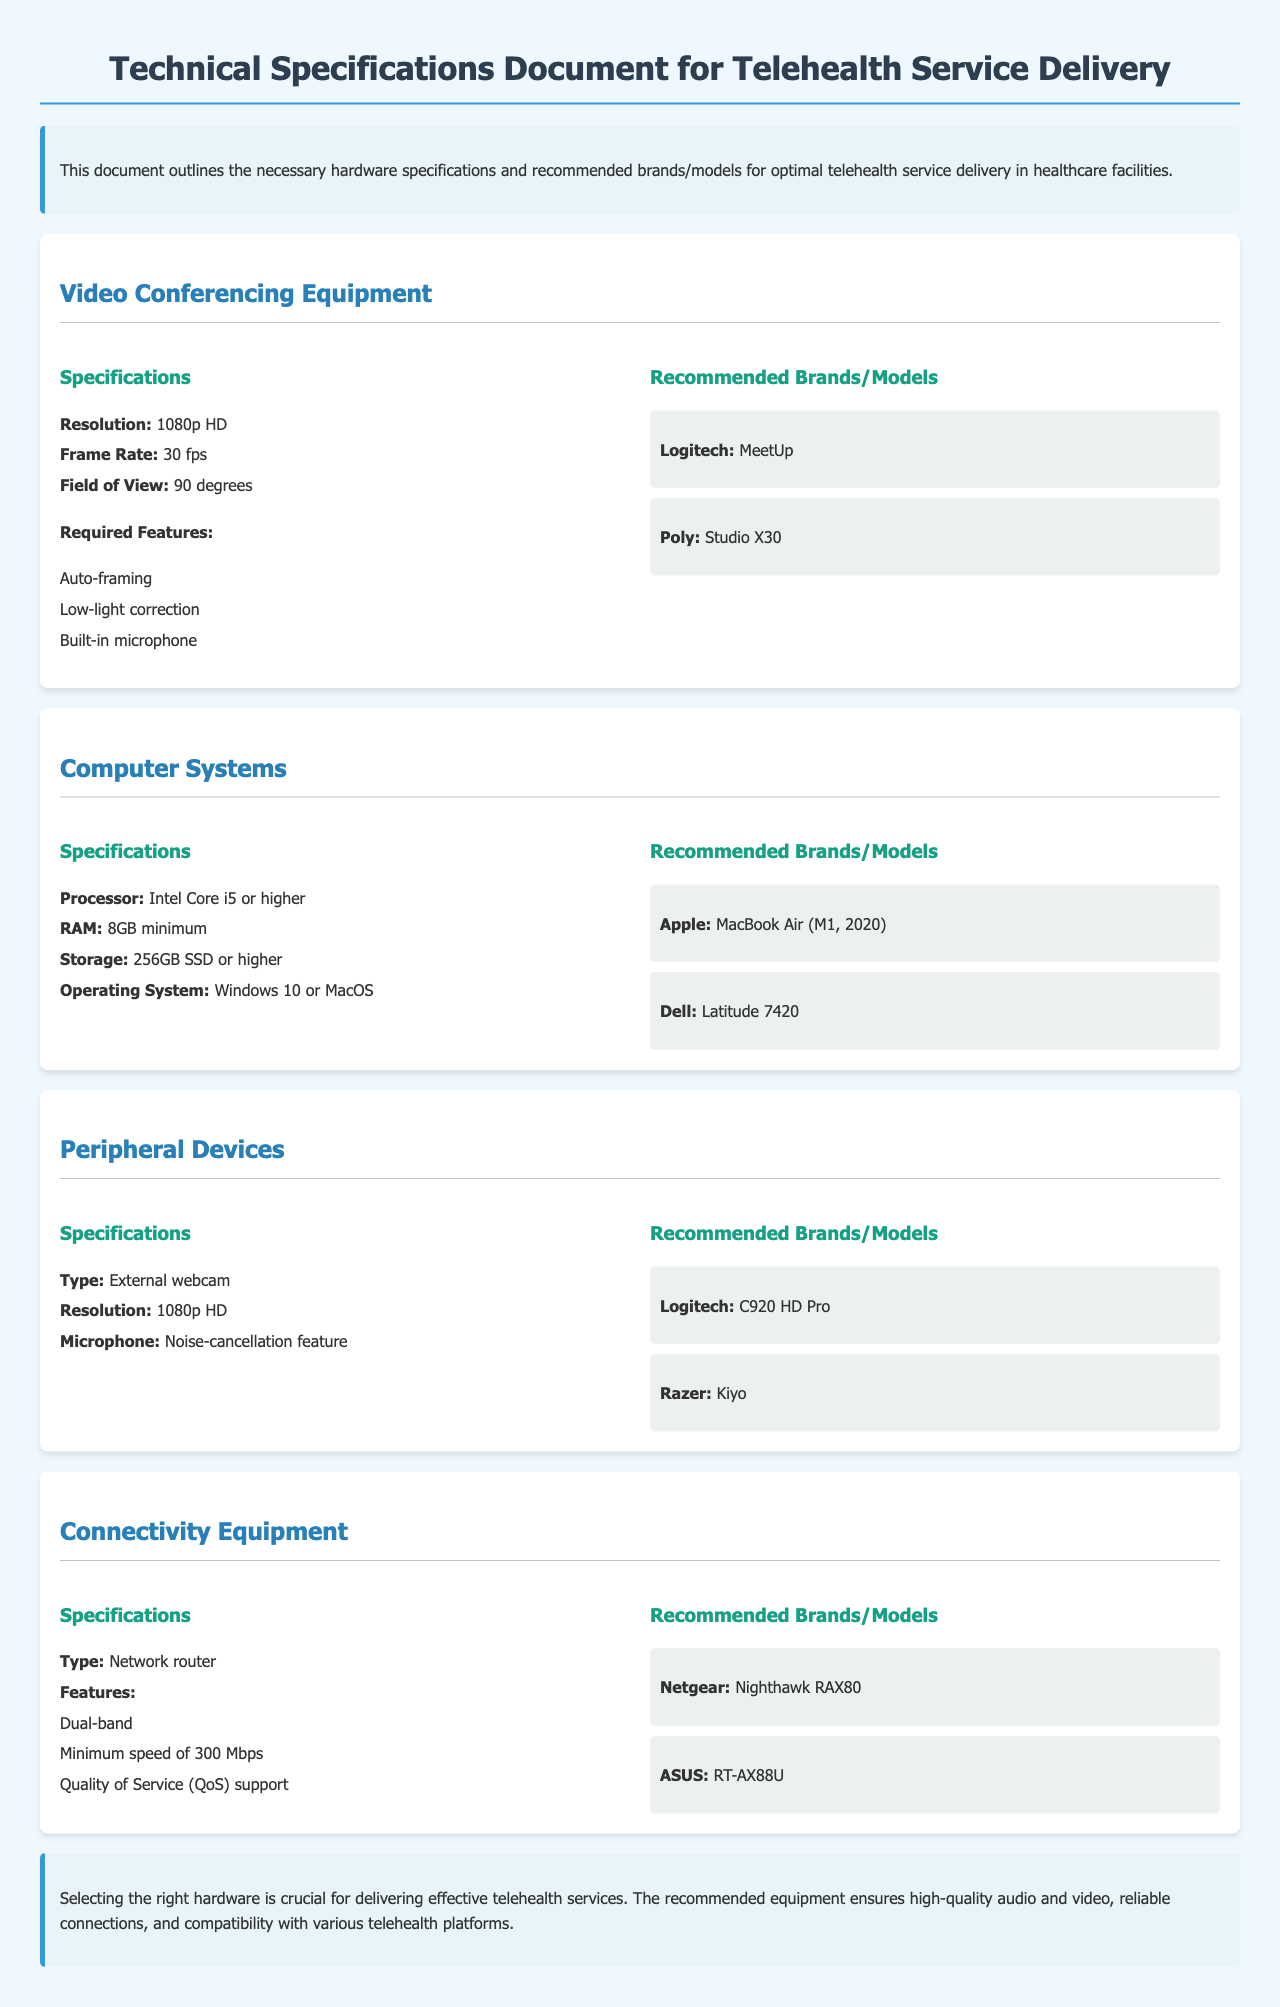What is the recommended resolution for video conferencing equipment? The document states that the recommended resolution is 1080p HD.
Answer: 1080p HD How many brands/models are suggested for computer systems? There are two recommended brands/models given for computer systems in the document.
Answer: 2 What is the minimum RAM requirement for the specified computer systems? The document specifies that the minimum RAM requirement is 8GB.
Answer: 8GB Which brand and model are recommended for connectivity equipment? The document lists two recommended brands/models for connectivity equipment, which include Netgear Nighthawk RAX80 and ASUS RT-AX88U.
Answer: Netgear Nighthawk RAX80 and ASUS RT-AX88U What type of external device is recommended with noise-cancellation feature? The document recommends an external webcam that has a noise-cancellation feature.
Answer: External webcam What feature is required in video conferencing equipment? The document states that auto-framing is a necessary feature for video conferencing equipment.
Answer: Auto-framing What is the recommended processor type for computer systems? The document specifies that the recommended processor is Intel Core i5 or higher.
Answer: Intel Core i5 or higher What speed is specified for the minimum connectivity equipment? The document mentions a minimum speed requirement of 300 Mbps for connectivity equipment.
Answer: 300 Mbps What is the intended purpose of the document? The purpose of the document is to outline hardware specifications for optimal telehealth service delivery in healthcare facilities.
Answer: To outline hardware specifications for telehealth service delivery 